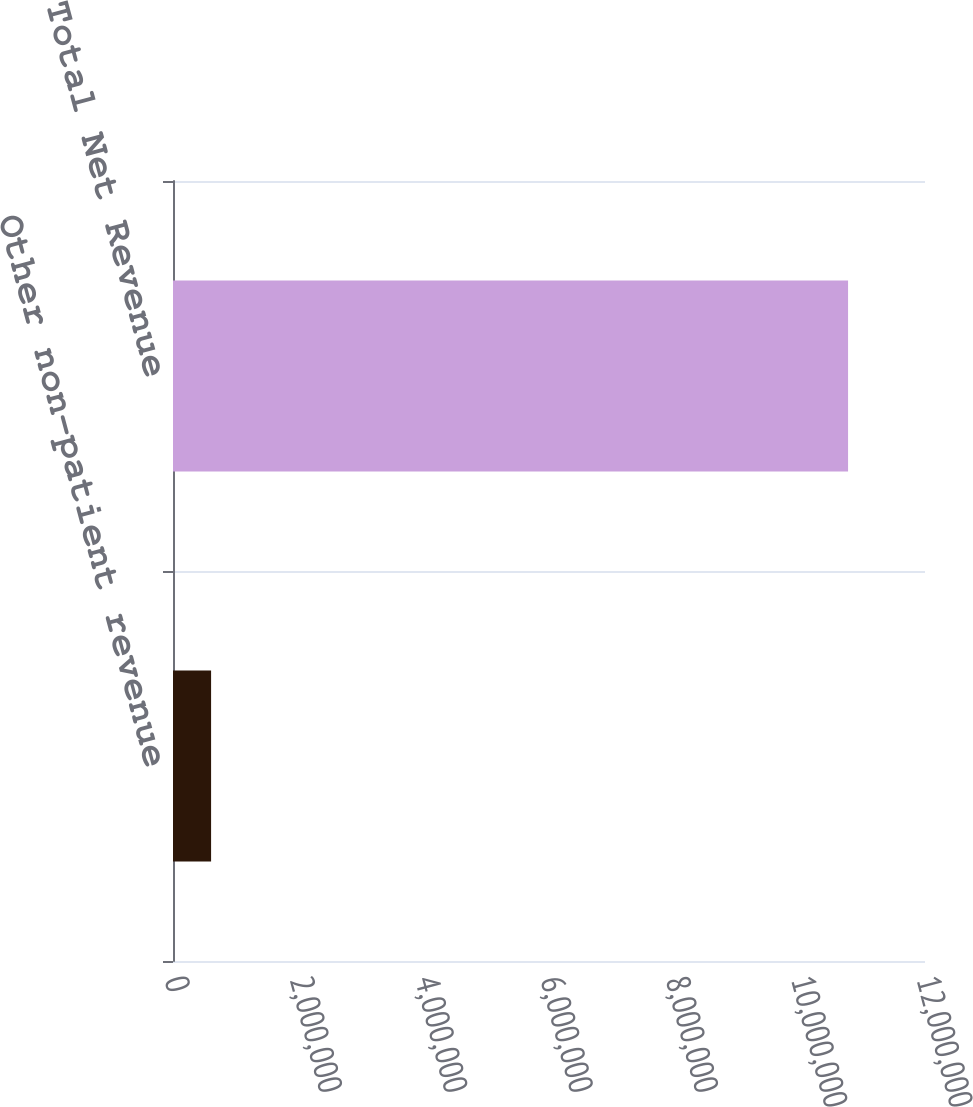Convert chart to OTSL. <chart><loc_0><loc_0><loc_500><loc_500><bar_chart><fcel>Other non-patient revenue<fcel>Total Net Revenue<nl><fcel>607812<fcel>1.07723e+07<nl></chart> 